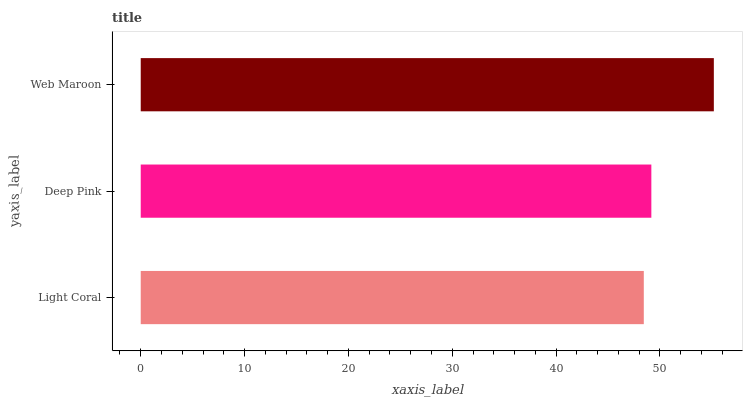Is Light Coral the minimum?
Answer yes or no. Yes. Is Web Maroon the maximum?
Answer yes or no. Yes. Is Deep Pink the minimum?
Answer yes or no. No. Is Deep Pink the maximum?
Answer yes or no. No. Is Deep Pink greater than Light Coral?
Answer yes or no. Yes. Is Light Coral less than Deep Pink?
Answer yes or no. Yes. Is Light Coral greater than Deep Pink?
Answer yes or no. No. Is Deep Pink less than Light Coral?
Answer yes or no. No. Is Deep Pink the high median?
Answer yes or no. Yes. Is Deep Pink the low median?
Answer yes or no. Yes. Is Light Coral the high median?
Answer yes or no. No. Is Web Maroon the low median?
Answer yes or no. No. 